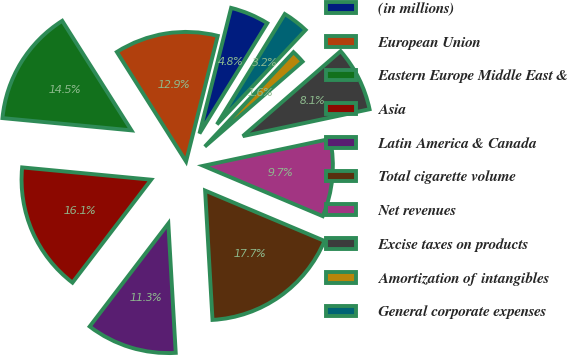Convert chart. <chart><loc_0><loc_0><loc_500><loc_500><pie_chart><fcel>(in millions)<fcel>European Union<fcel>Eastern Europe Middle East &<fcel>Asia<fcel>Latin America & Canada<fcel>Total cigarette volume<fcel>Net revenues<fcel>Excise taxes on products<fcel>Amortization of intangibles<fcel>General corporate expenses<nl><fcel>4.84%<fcel>12.9%<fcel>14.52%<fcel>16.13%<fcel>11.29%<fcel>17.74%<fcel>9.68%<fcel>8.06%<fcel>1.61%<fcel>3.23%<nl></chart> 